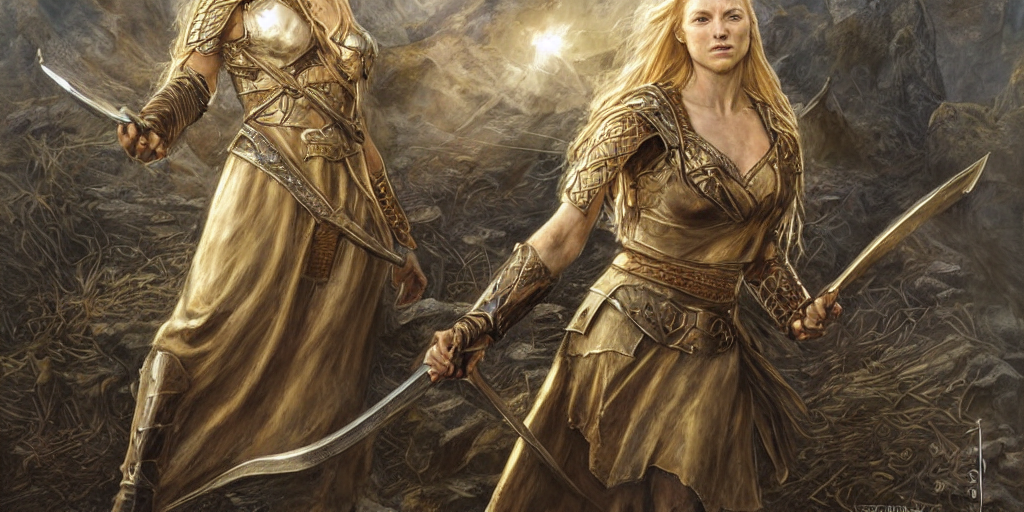What is the mood or emotion conveyed by the characters? The characters exude a sense of determination and resilience. Their stern expressions and assertive stances convey readiness for combat or defense. The image depicts them as fierce and focused, possibly suggesting an imminent conflict or a moment of guarded peace. 